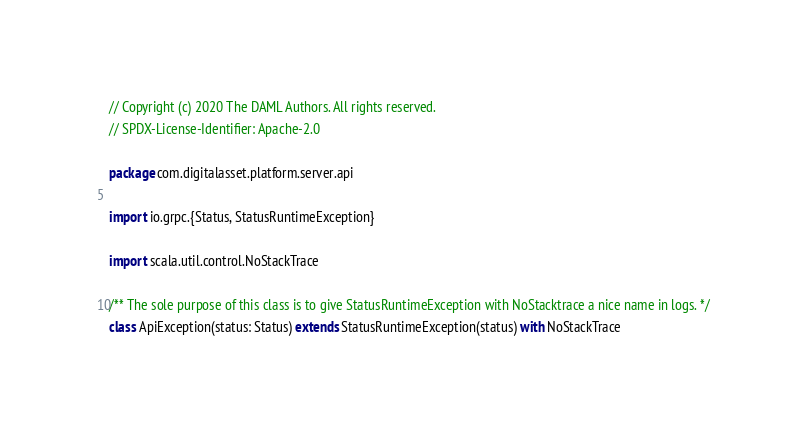<code> <loc_0><loc_0><loc_500><loc_500><_Scala_>// Copyright (c) 2020 The DAML Authors. All rights reserved.
// SPDX-License-Identifier: Apache-2.0

package com.digitalasset.platform.server.api

import io.grpc.{Status, StatusRuntimeException}

import scala.util.control.NoStackTrace

/** The sole purpose of this class is to give StatusRuntimeException with NoStacktrace a nice name in logs. */
class ApiException(status: Status) extends StatusRuntimeException(status) with NoStackTrace
</code> 